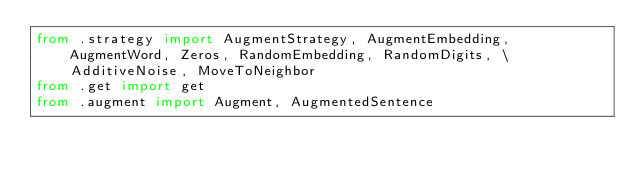Convert code to text. <code><loc_0><loc_0><loc_500><loc_500><_Python_>from .strategy import AugmentStrategy, AugmentEmbedding, AugmentWord, Zeros, RandomEmbedding, RandomDigits, \
    AdditiveNoise, MoveToNeighbor
from .get import get
from .augment import Augment, AugmentedSentence


</code> 